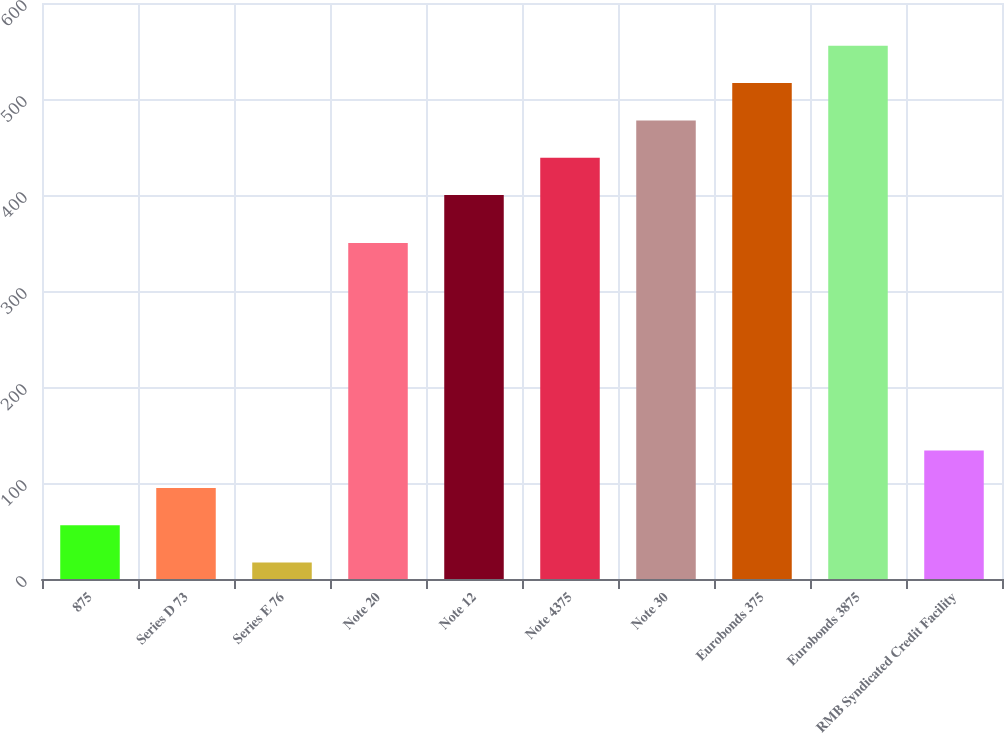Convert chart to OTSL. <chart><loc_0><loc_0><loc_500><loc_500><bar_chart><fcel>875<fcel>Series D 73<fcel>Series E 76<fcel>Note 20<fcel>Note 12<fcel>Note 4375<fcel>Note 30<fcel>Eurobonds 375<fcel>Eurobonds 3875<fcel>RMB Syndicated Credit Facility<nl><fcel>56.05<fcel>94.9<fcel>17.2<fcel>350<fcel>400<fcel>438.85<fcel>477.7<fcel>516.55<fcel>555.4<fcel>133.75<nl></chart> 